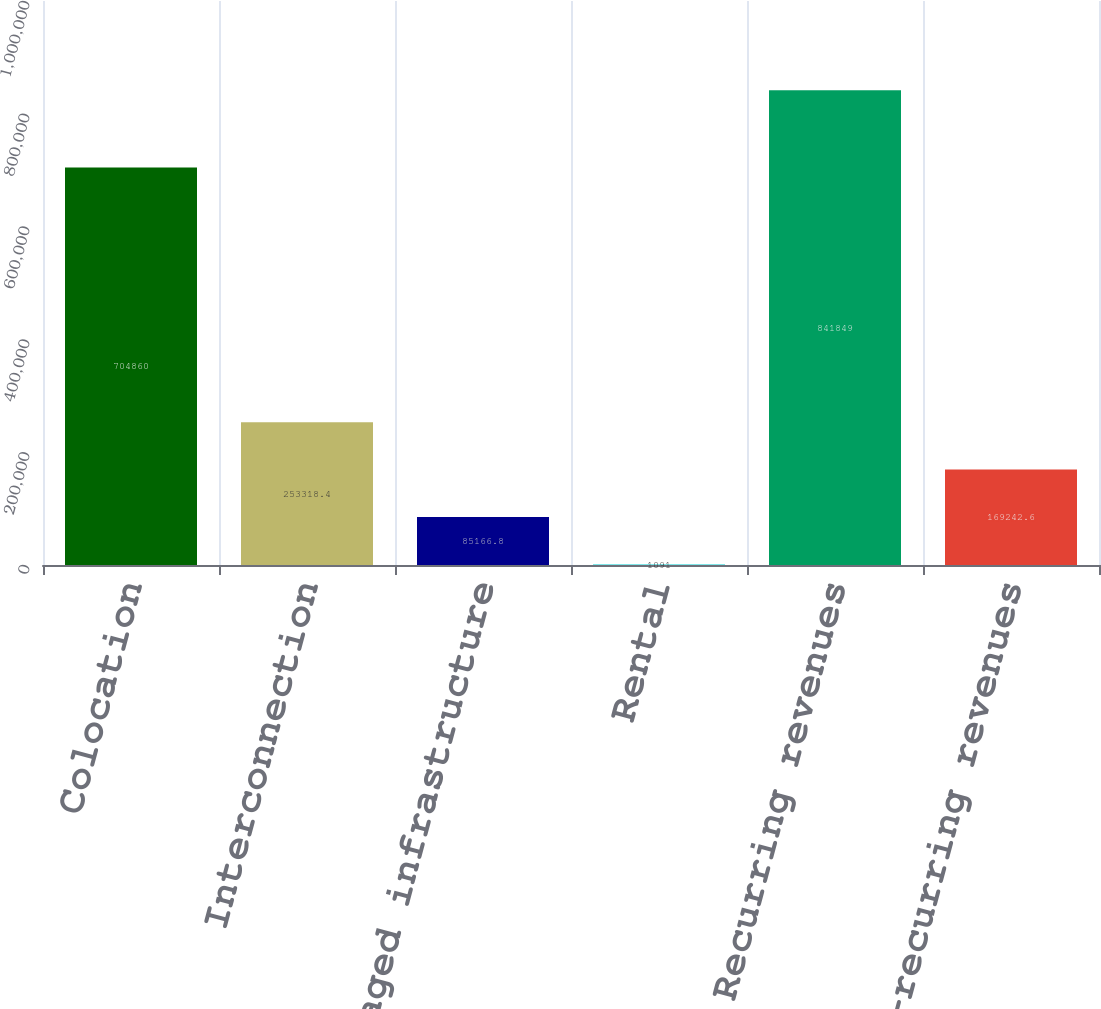Convert chart. <chart><loc_0><loc_0><loc_500><loc_500><bar_chart><fcel>Colocation<fcel>Interconnection<fcel>Managed infrastructure<fcel>Rental<fcel>Recurring revenues<fcel>Non-recurring revenues<nl><fcel>704860<fcel>253318<fcel>85166.8<fcel>1091<fcel>841849<fcel>169243<nl></chart> 